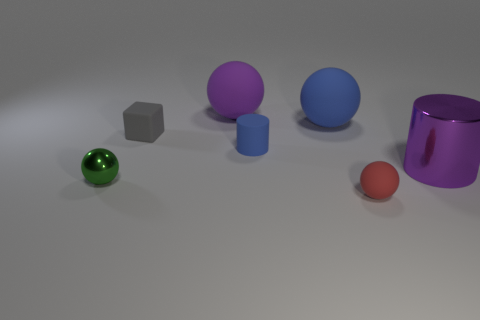Are there any other things that are the same color as the small metallic object?
Make the answer very short. No. There is a purple rubber object that is on the left side of the large blue object; what number of small red matte balls are on the left side of it?
Your answer should be compact. 0. There is a metal thing that is left of the block; does it have the same shape as the blue object that is behind the small gray block?
Your response must be concise. Yes. The matte object that is the same color as the big metallic thing is what shape?
Your response must be concise. Sphere. Is there a small blue object that has the same material as the gray block?
Provide a succinct answer. Yes. How many matte objects are large blue objects or tiny blue things?
Your answer should be compact. 2. What is the shape of the blue matte thing that is in front of the gray rubber thing that is left of the big purple cylinder?
Your answer should be compact. Cylinder. Is the number of tiny blue matte cylinders behind the small blue cylinder less than the number of large purple things?
Keep it short and to the point. Yes. The tiny blue matte thing is what shape?
Your answer should be compact. Cylinder. What is the size of the cylinder in front of the tiny blue rubber thing?
Offer a terse response. Large. 